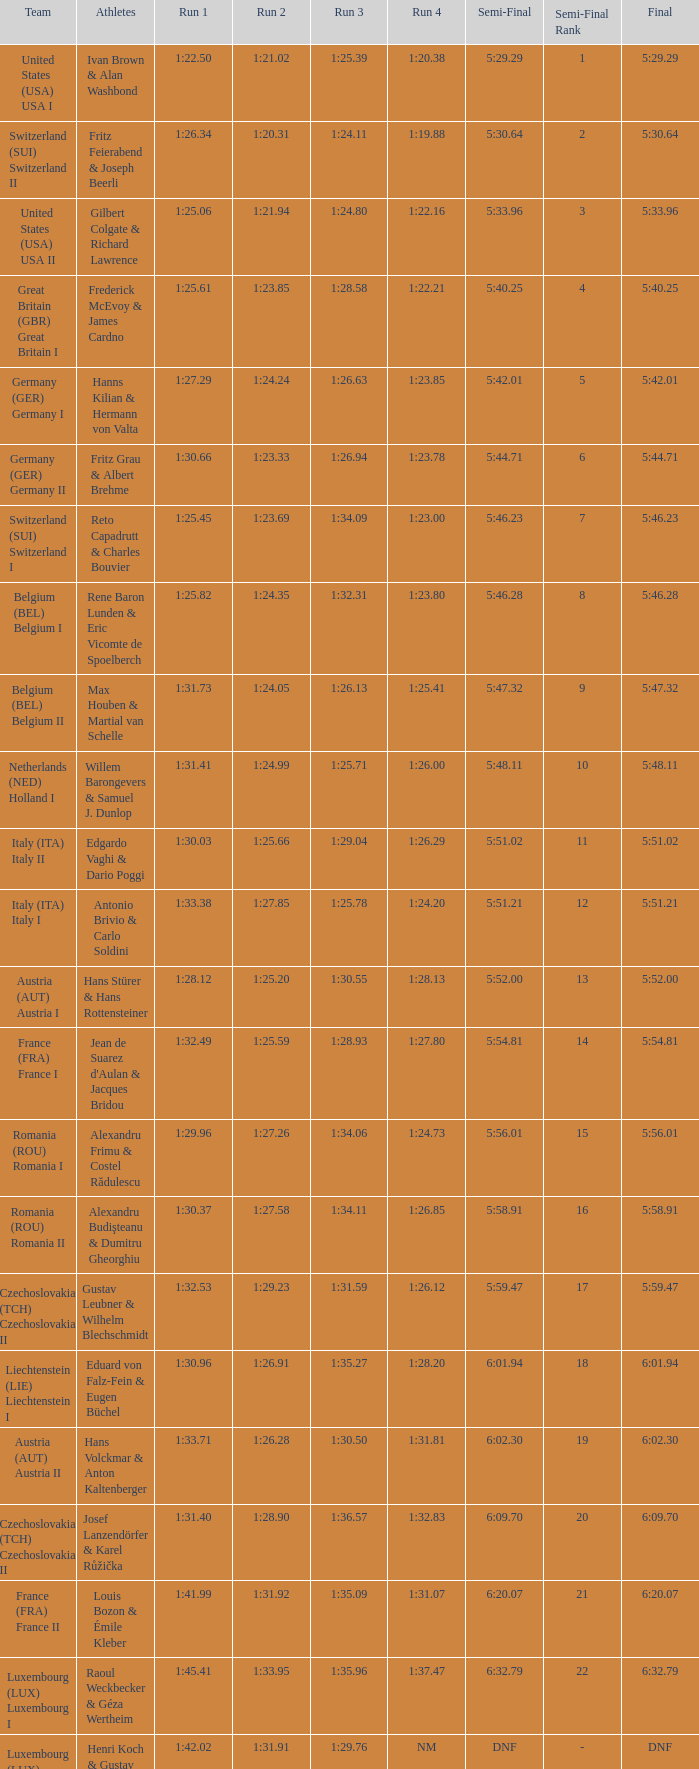Which Run 4 has Athletes of alexandru frimu & costel rădulescu? 1:24.73. 